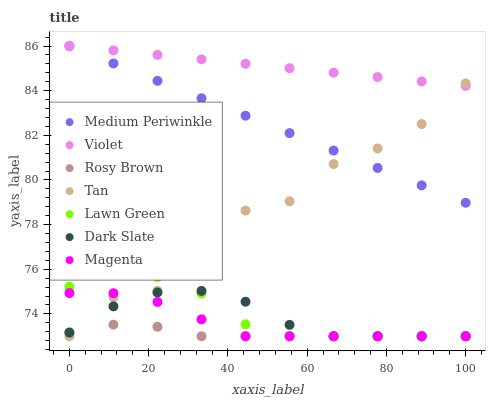Does Rosy Brown have the minimum area under the curve?
Answer yes or no. Yes. Does Violet have the maximum area under the curve?
Answer yes or no. Yes. Does Medium Periwinkle have the minimum area under the curve?
Answer yes or no. No. Does Medium Periwinkle have the maximum area under the curve?
Answer yes or no. No. Is Violet the smoothest?
Answer yes or no. Yes. Is Tan the roughest?
Answer yes or no. Yes. Is Rosy Brown the smoothest?
Answer yes or no. No. Is Rosy Brown the roughest?
Answer yes or no. No. Does Lawn Green have the lowest value?
Answer yes or no. Yes. Does Medium Periwinkle have the lowest value?
Answer yes or no. No. Does Violet have the highest value?
Answer yes or no. Yes. Does Rosy Brown have the highest value?
Answer yes or no. No. Is Magenta less than Medium Periwinkle?
Answer yes or no. Yes. Is Medium Periwinkle greater than Lawn Green?
Answer yes or no. Yes. Does Medium Periwinkle intersect Violet?
Answer yes or no. Yes. Is Medium Periwinkle less than Violet?
Answer yes or no. No. Is Medium Periwinkle greater than Violet?
Answer yes or no. No. Does Magenta intersect Medium Periwinkle?
Answer yes or no. No. 